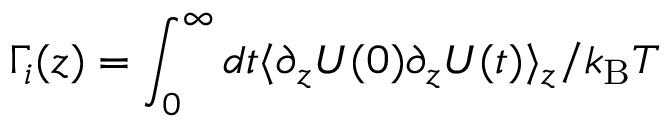Convert formula to latex. <formula><loc_0><loc_0><loc_500><loc_500>\Gamma _ { i } ( z ) = \int _ { 0 } ^ { \infty } d t \langle \partial _ { z } U ( 0 ) \partial _ { z } U ( t ) \rangle _ { z } / k _ { B } T</formula> 